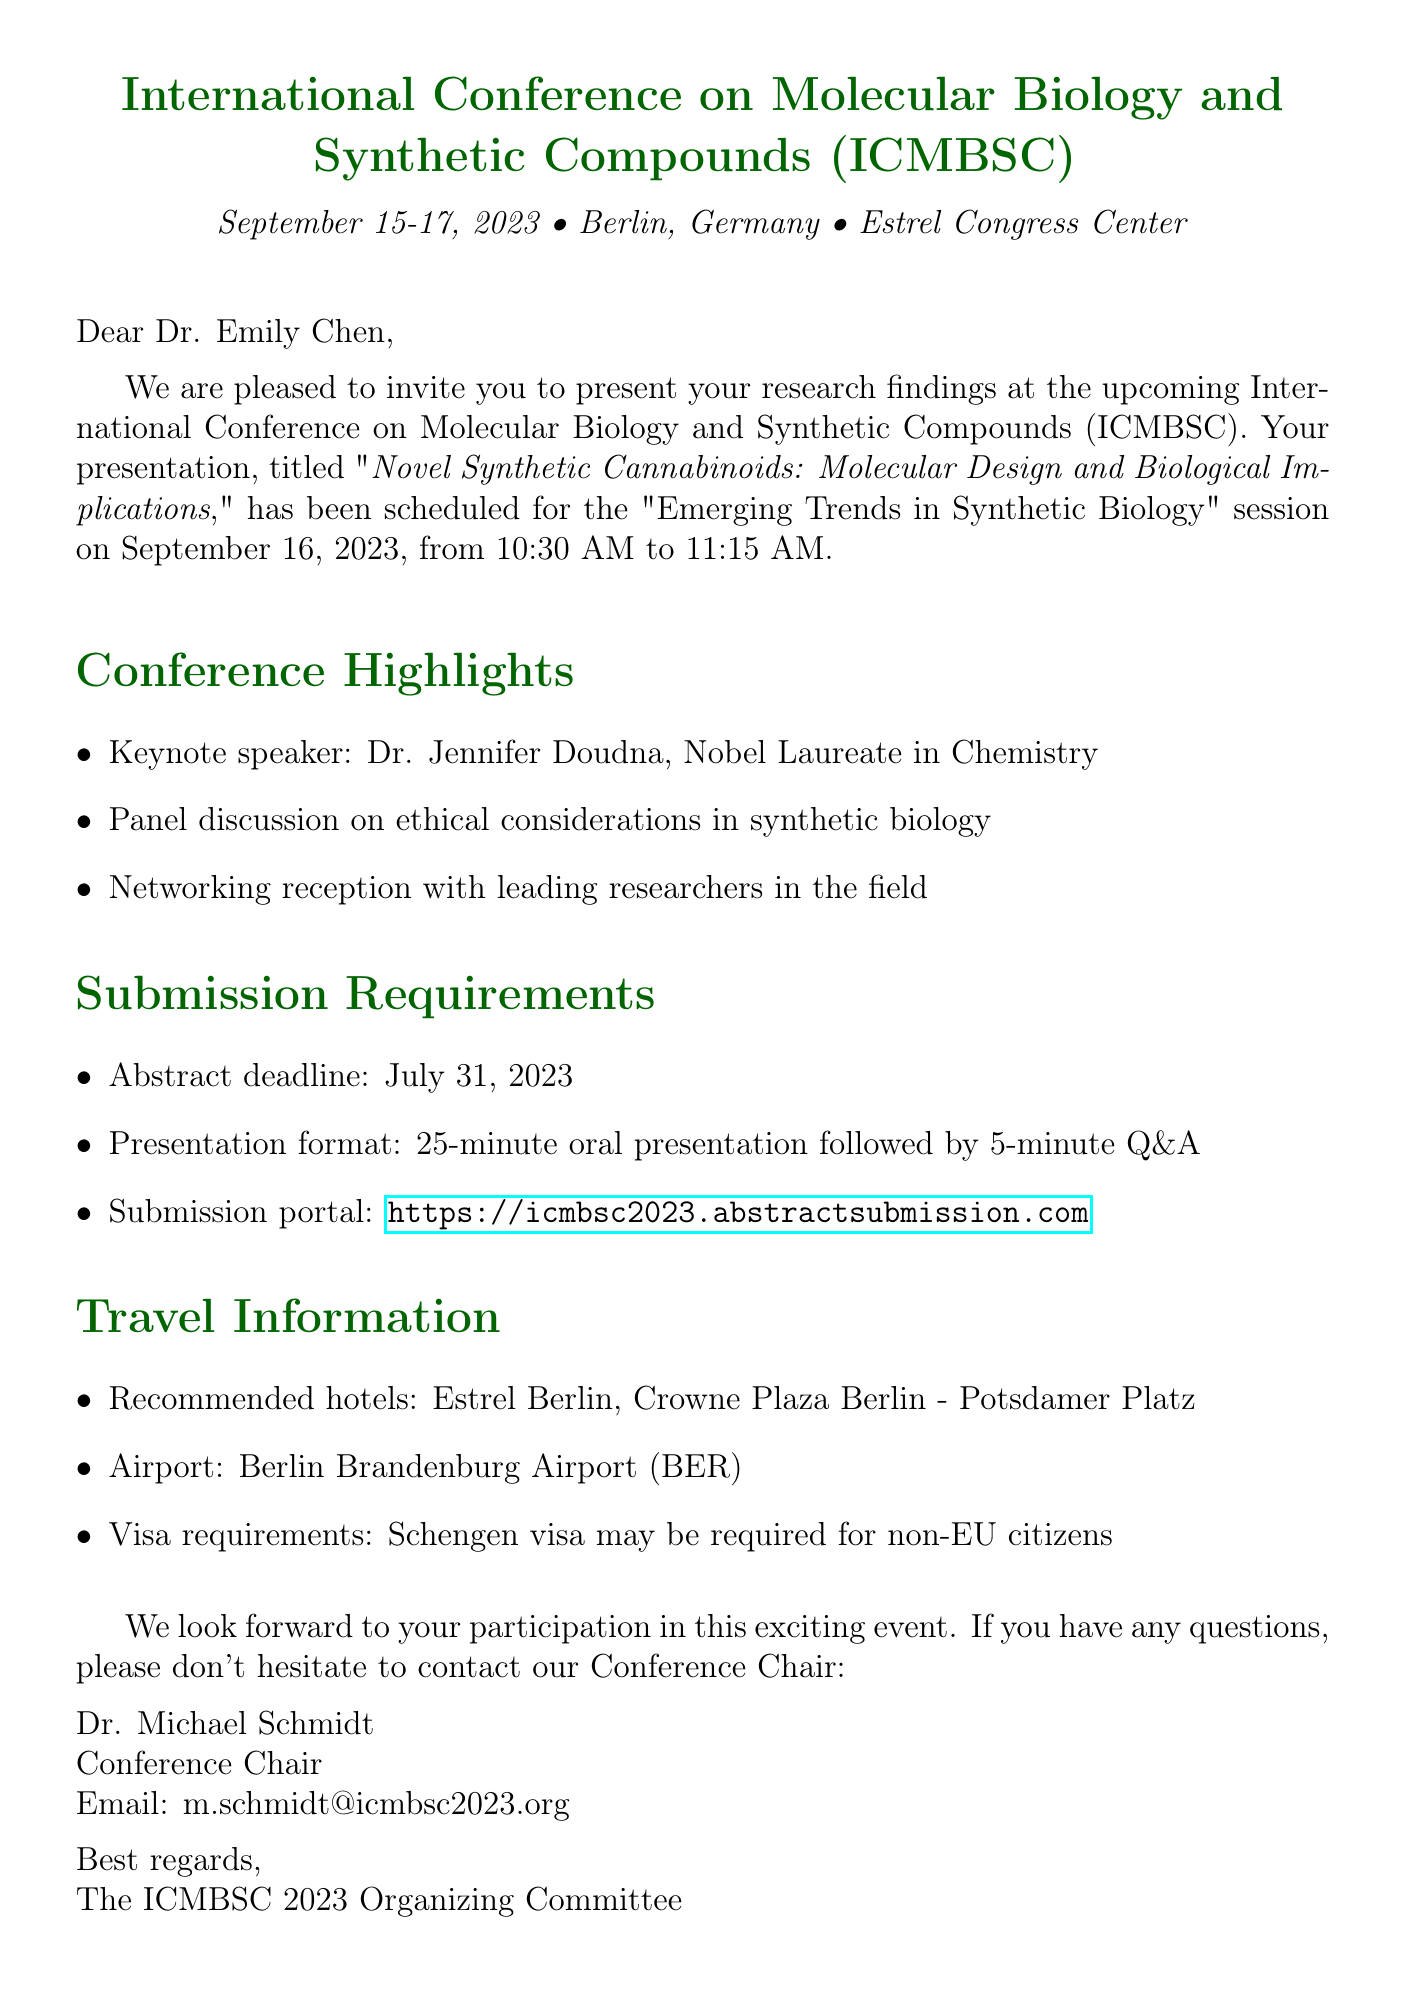What are the dates of the conference? The conference is scheduled to take place from September 15 to September 17, 2023.
Answer: September 15-17, 2023 Who is the keynote speaker? The document states that Dr. Jennifer Doudna, a Nobel Laureate in Chemistry, will be the keynote speaker.
Answer: Dr. Jennifer Doudna What is the title of the presentation? The title of the presentation given in the document is "Novel Synthetic Cannabinoids: Molecular Design and Biological Implications."
Answer: Novel Synthetic Cannabinoids: Molecular Design and Biological Implications What is the length of the presentation? The document specifies that the presentation format includes a 25-minute oral presentation followed by a 5-minute Q&A session.
Answer: 25 minutes What is the location of the conference? According to the document, the conference will be held at the Estrel Congress Center in Berlin, Germany.
Answer: Estrel Congress Center What is the deadline for abstract submission? The abstract deadline mentioned in the document is July 31, 2023.
Answer: July 31, 2023 Is a visa required for non-EU citizens? The document indicates that a Schengen visa may be required for non-EU citizens.
Answer: Yes Who can I contact for more information? The contact person listed in the document is Dr. Michael Schmidt, the Conference Chair.
Answer: Dr. Michael Schmidt What is the email address for the conference chair? Dr. Michael Schmidt's email address is provided as m.schmidt@icmbsc2023.org.
Answer: m.schmidt@icmbsc2023.org 